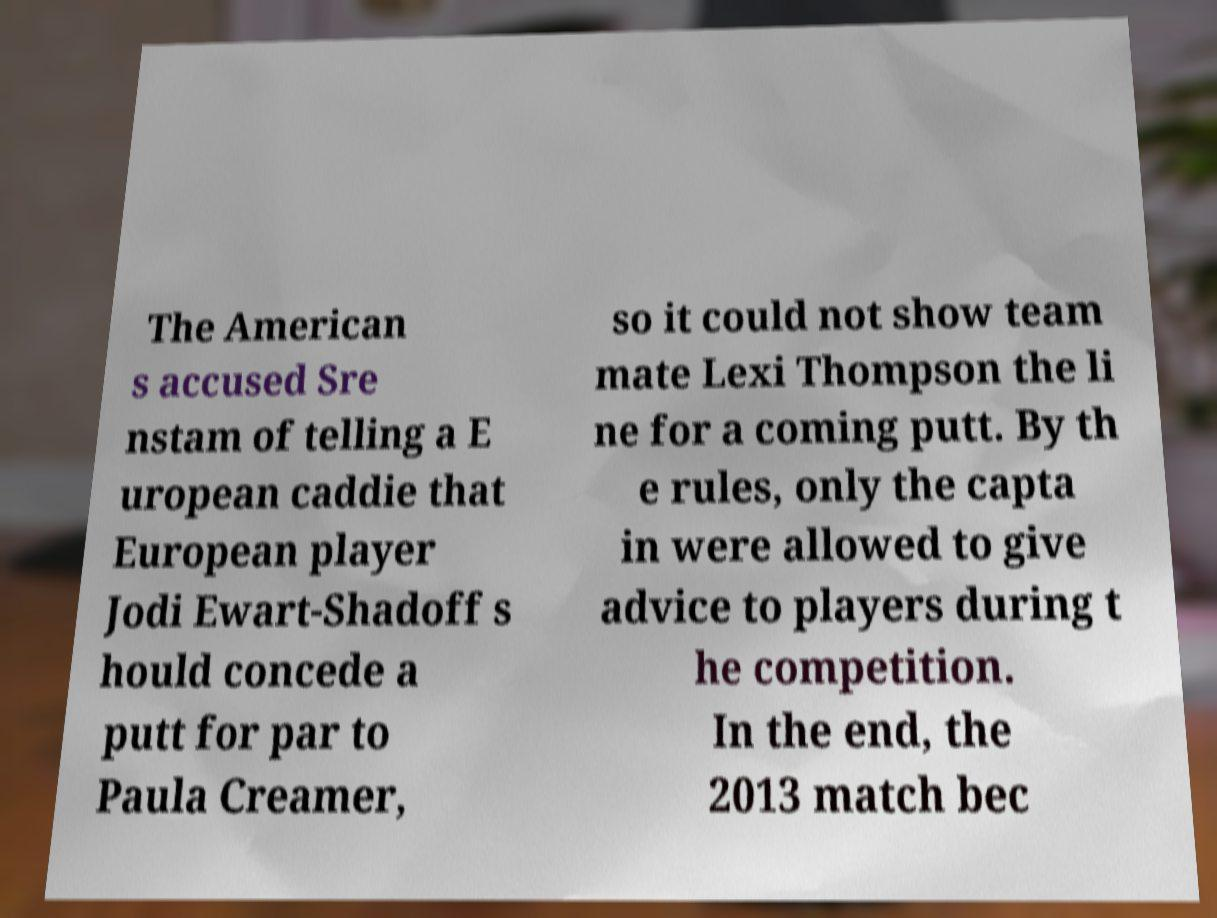What messages or text are displayed in this image? I need them in a readable, typed format. The American s accused Sre nstam of telling a E uropean caddie that European player Jodi Ewart-Shadoff s hould concede a putt for par to Paula Creamer, so it could not show team mate Lexi Thompson the li ne for a coming putt. By th e rules, only the capta in were allowed to give advice to players during t he competition. In the end, the 2013 match bec 